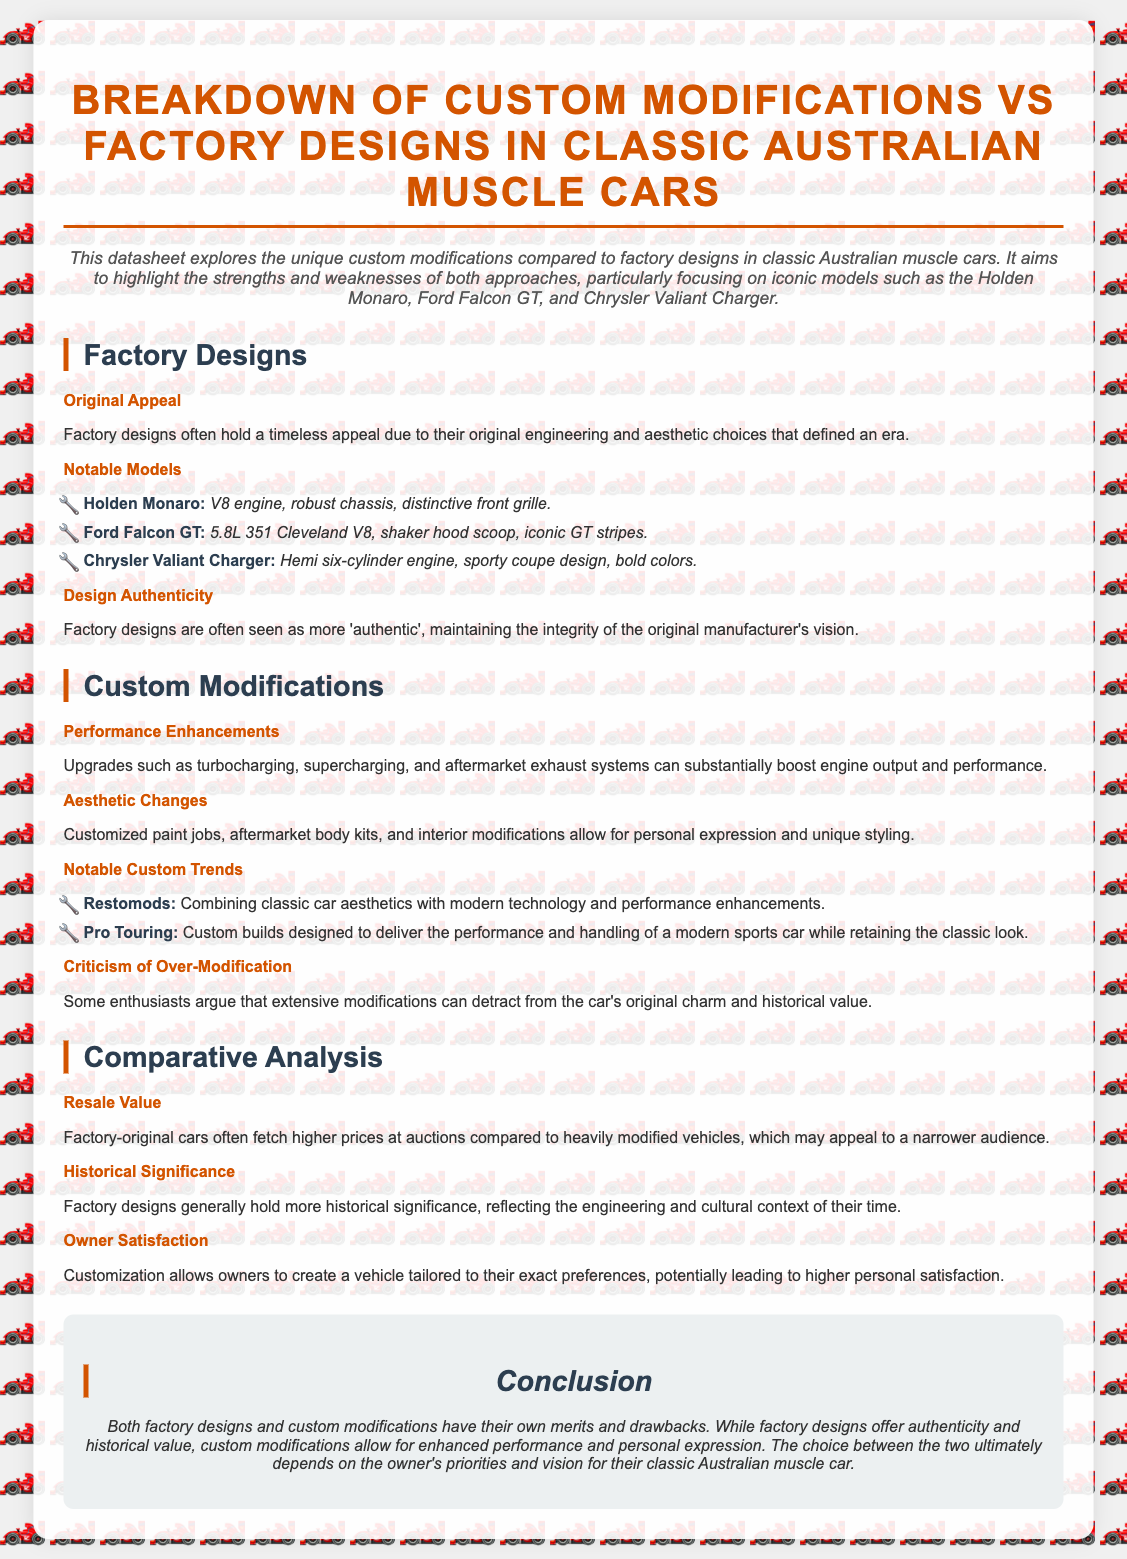What is the title of the datasheet? The title of the datasheet is prominently displayed at the top, expressing the focus on modifications versus factory designs in a specific context.
Answer: Breakdown of Custom Modifications vs Factory Designs in Classic Australian Muscle Cars Which model is associated with a Hemi six-cylinder engine? The datasheet lists specific features for various models, including the engine type for each.
Answer: Chrysler Valiant Charger What is a key feature of the Ford Falcon GT? The datasheet specifically highlights notable features for each model, showing distinct characteristics that define them.
Answer: 5.8L 351 Cleveland V8 What customization trend combines classic aesthetics with modern technology? The document outlines current custom modification trends, providing specific terms that describe these approaches.
Answer: Restomods What do factory-original cars generally fetch at auctions compared to heavily modified vehicles? The document discusses resale value comparisons between different types of car designs and their market appeal.
Answer: Higher prices Which car's design is noted for its distinctive front grille? The datasheet highlights specific design elements associated with recognized classic Australian muscle cars.
Answer: Holden Monaro What is a notable criticism of extensive modifications? The document mentions potential downsides of custom modifications in relation to the car's original appeal and historical context.
Answer: Detracts from original charm What does customization allow owners to create? The datasheet emphasizes the benefits of customization for car owners, showcasing personal satisfaction aspects.
Answer: A vehicle tailored to their exact preferences 